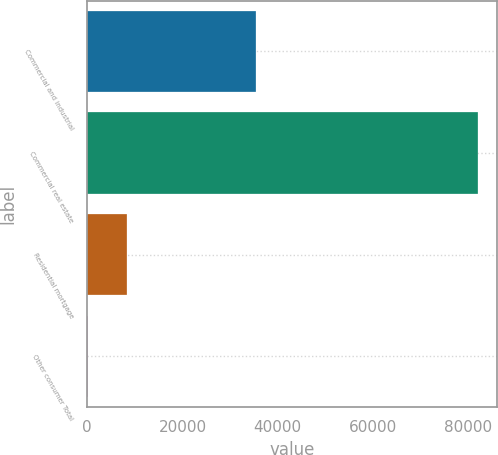Convert chart to OTSL. <chart><loc_0><loc_0><loc_500><loc_500><bar_chart><fcel>Commercial and industrial<fcel>Commercial real estate<fcel>Residential mortgage<fcel>Other consumer Total<nl><fcel>35526<fcel>82073<fcel>8323.4<fcel>129<nl></chart> 